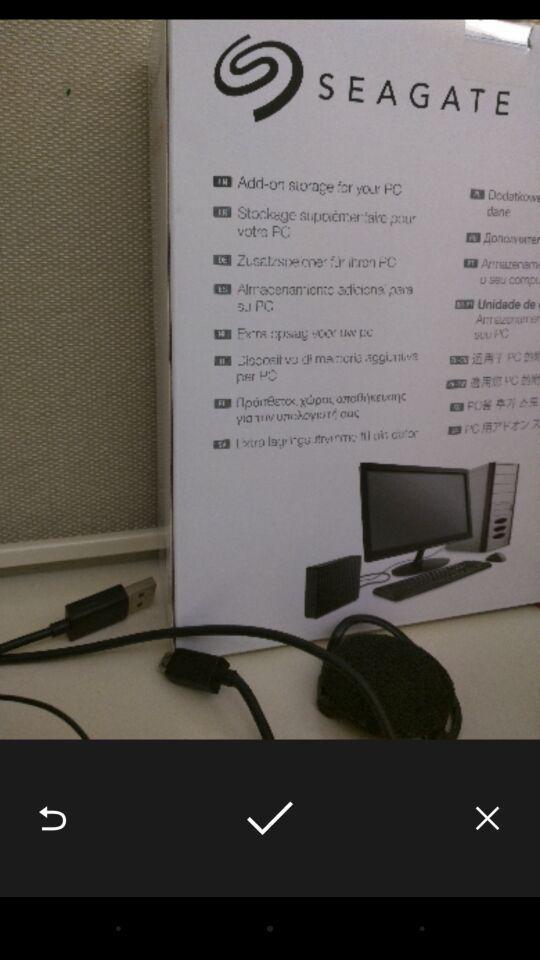Describe this image in words. Page showing image with save back and exit options. 